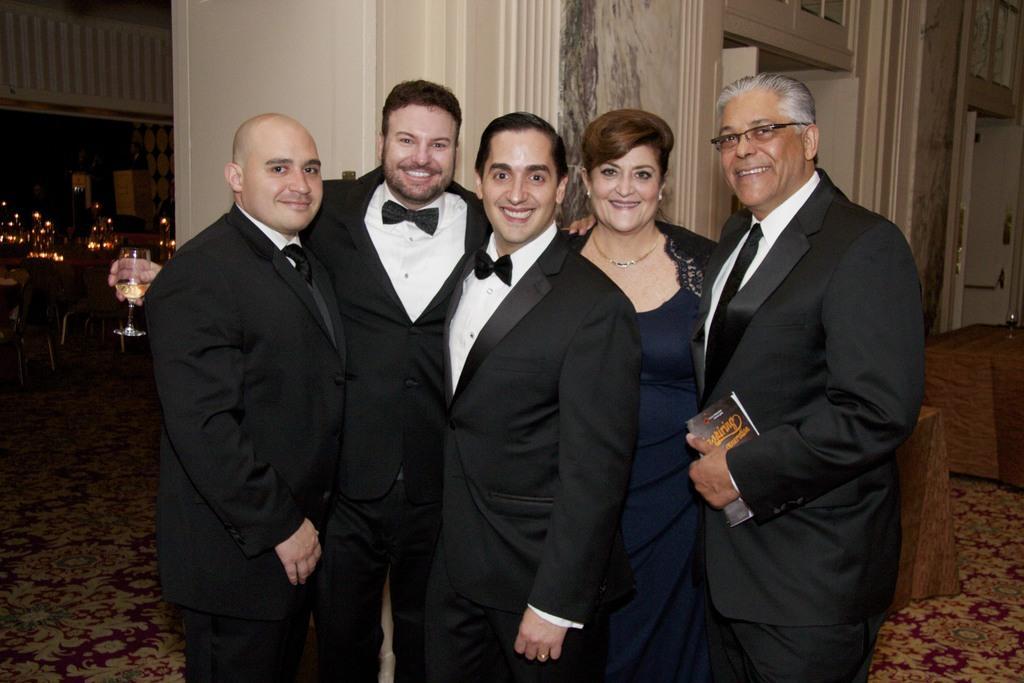How would you summarize this image in a sentence or two? In this picture we can see five persons standing and smiling, a man second from the left side is holding a glass of drink, in the background there are some chairs and tables, there is a door on the right side, a man on the right side is holding a book. 